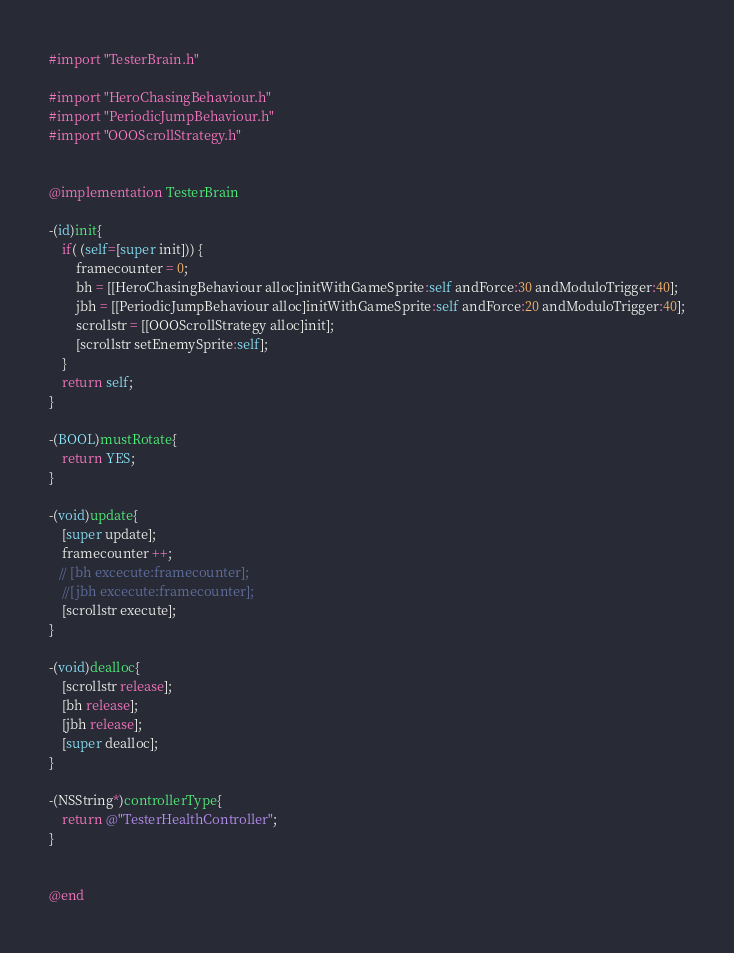<code> <loc_0><loc_0><loc_500><loc_500><_ObjectiveC_>
#import "TesterBrain.h"

#import "HeroChasingBehaviour.h"
#import "PeriodicJumpBehaviour.h"
#import "OOOScrollStrategy.h"


@implementation TesterBrain

-(id)init{
    if( (self=[super init])) {
        framecounter = 0;
        bh = [[HeroChasingBehaviour alloc]initWithGameSprite:self andForce:30 andModuloTrigger:40];
        jbh = [[PeriodicJumpBehaviour alloc]initWithGameSprite:self andForce:20 andModuloTrigger:40];
        scrollstr = [[OOOScrollStrategy alloc]init];
        [scrollstr setEnemySprite:self];
    }
    return self;
}

-(BOOL)mustRotate{
    return YES;
}

-(void)update{
    [super update];
    framecounter ++;
   // [bh excecute:framecounter];
    //[jbh excecute:framecounter];
    [scrollstr execute];
}

-(void)dealloc{
    [scrollstr release];
    [bh release];
    [jbh release];
    [super dealloc];
}

-(NSString*)controllerType{
    return @"TesterHealthController";
}


@end
</code> 